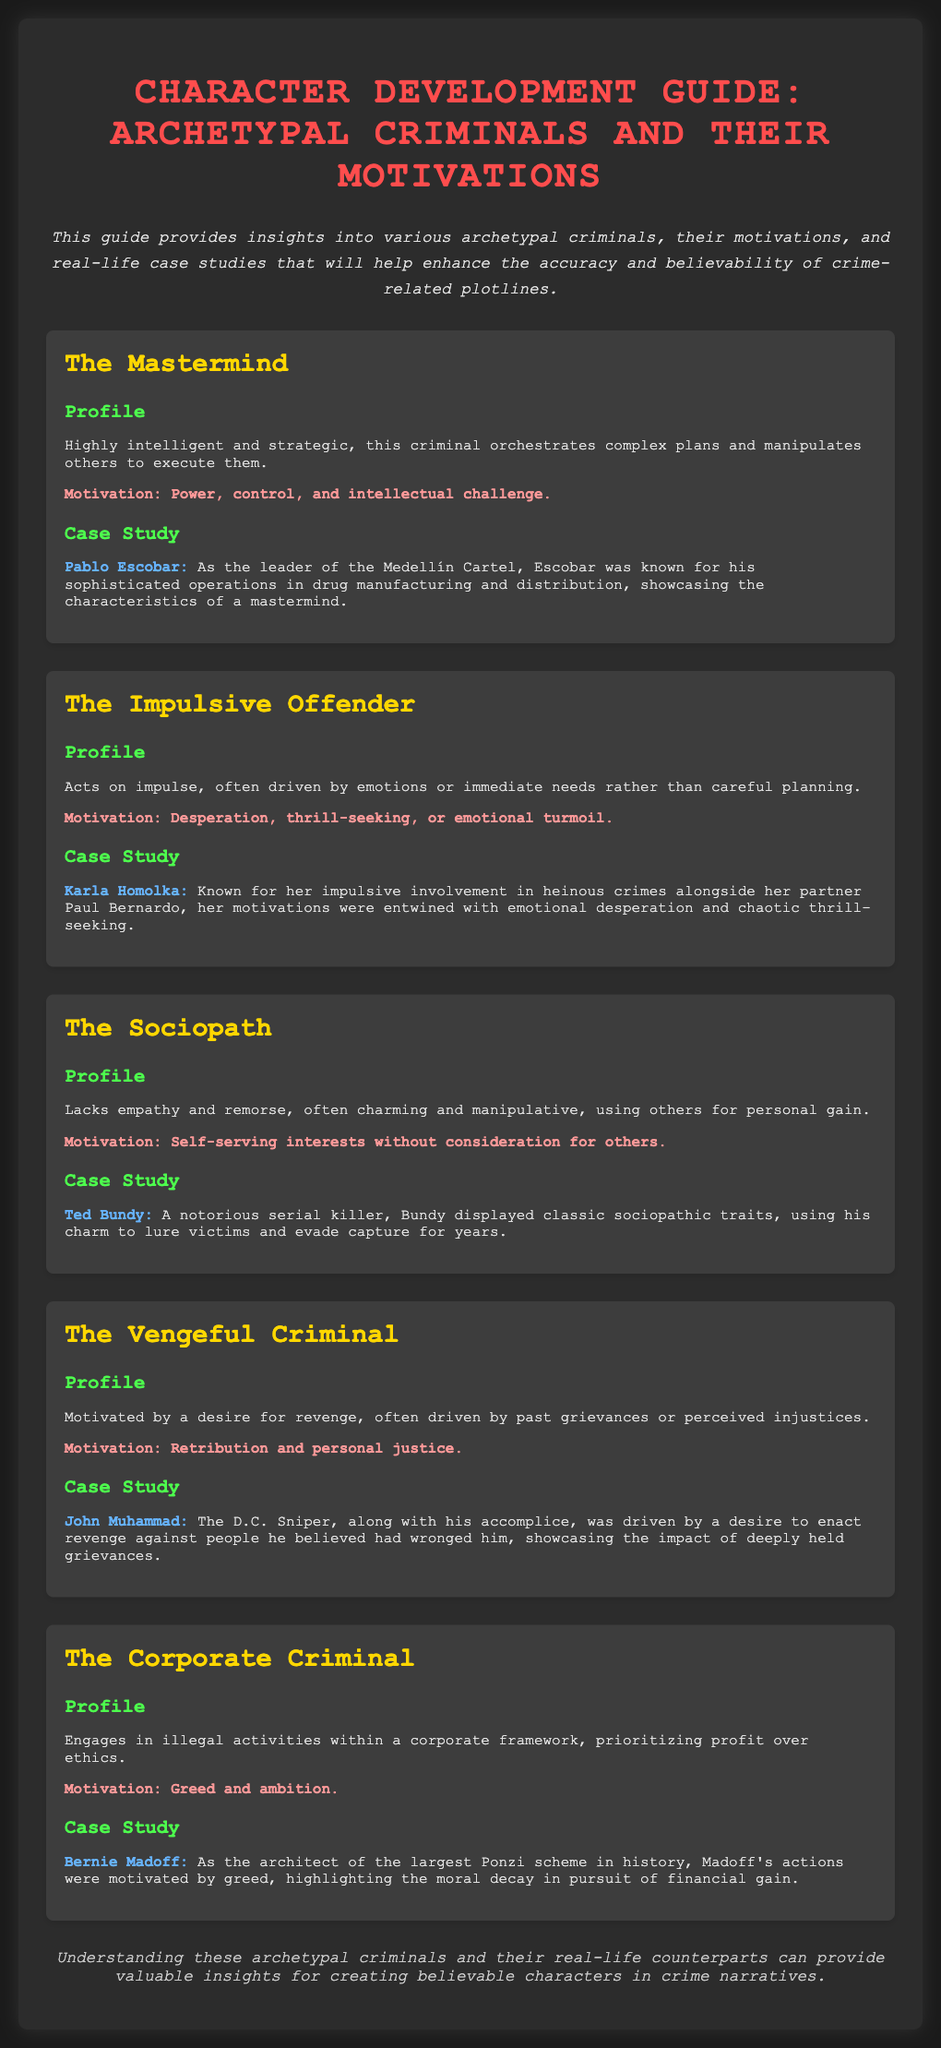What is the title of the guide? The title of the guide is prominently displayed at the top of the document, identifying its purpose.
Answer: Character Development Guide: Archetypal Criminals How many archetypes are discussed in the document? The document lists out five different archetypes of criminals, each with their own profiles and case studies.
Answer: Five Who is the case study for The Mastermind archetype? The case study section under The Mastermind archetype provides a specific example of a real-life individual illustrating that archetype.
Answer: Pablo Escobar What is the motivation for The Sociopath archetype? The motivation is stated clearly in relation to the characteristics of the archetype, emphasizing their self-serving nature.
Answer: Self-serving interests without consideration for others What criminal type is Karla Homolka associated with? The document clearly identifies her association based on her impulsive actions and emotional drivers.
Answer: The Impulsive Offender Which criminal is associated with corporate crime? The guide specifies individuals under specific archetypes, with one notably focusing on corporate crime.
Answer: Bernie Madoff What motivates The Vengeful Criminal? The profile describes this criminal's underlying reasoning that drives their actions, specifically reflecting on personal grievances.
Answer: Retribution and personal justice Who is described as lacking empathy and remorse? The document characterizes a specific type of criminal with these traits, directly naming an infamous individual as a case study.
Answer: Ted Bundy 